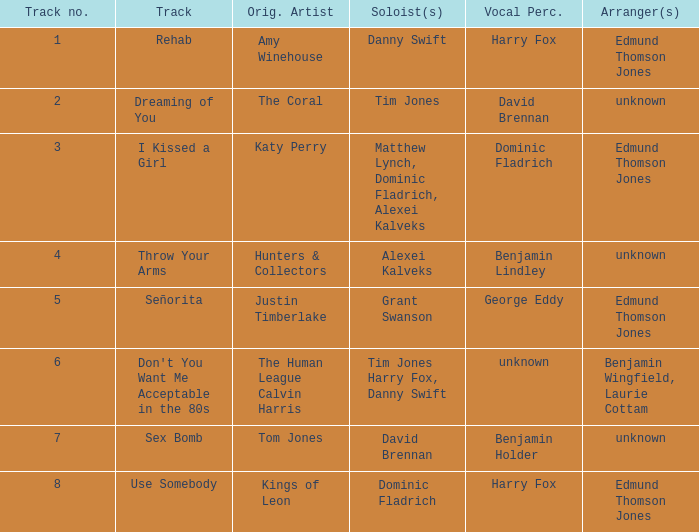Who is the vocal percussionist for Sex Bomb? Benjamin Holder. 